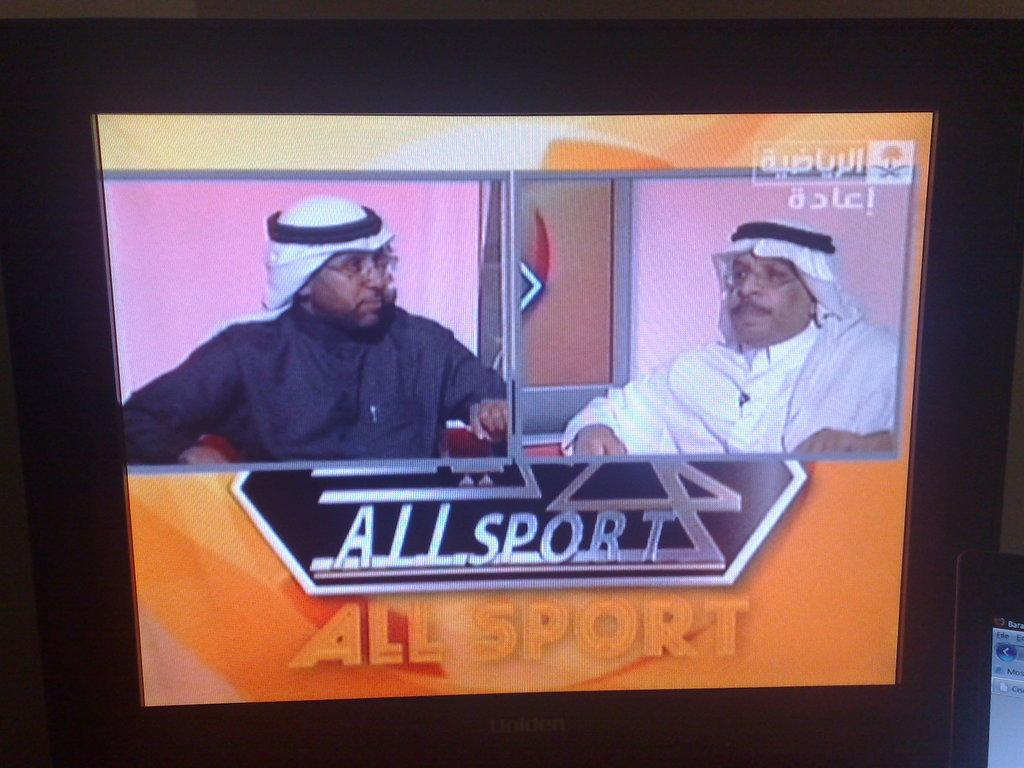<image>
Provide a brief description of the given image. Two men are on a TV screen with the words "all sport" displayed underneath them. 